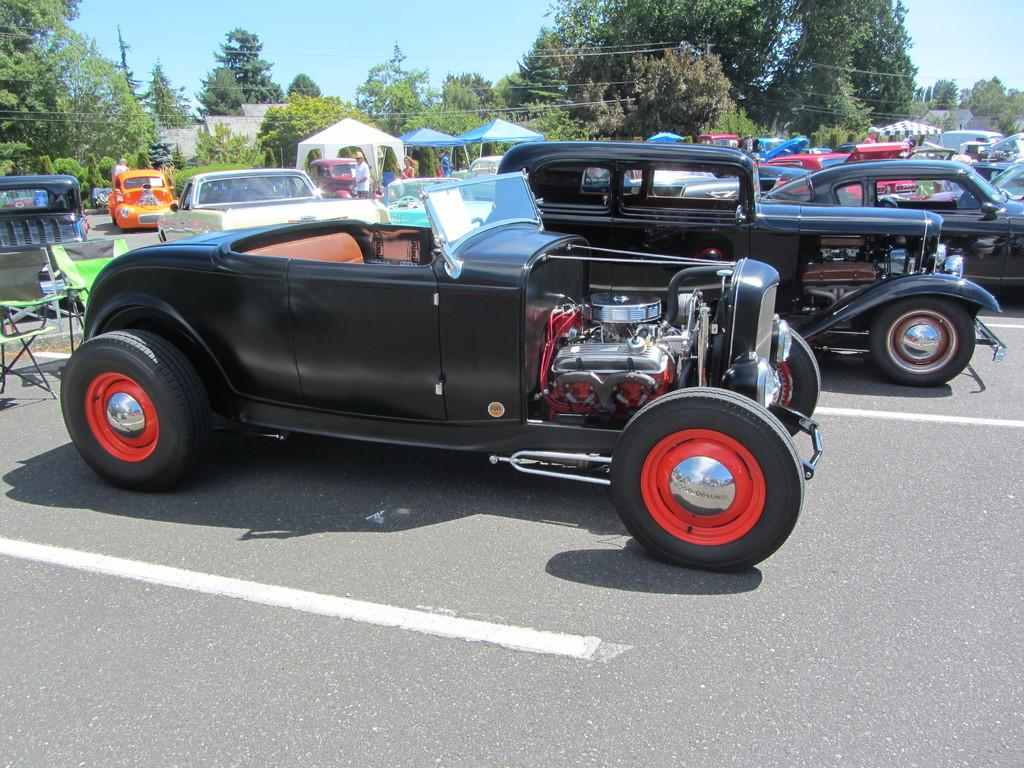What can be seen on the road in the image? There are vehicles on the road in the image. What type of furniture is present in the image? There are chairs in the image. What is visible in the background of the image? There is a roof top, trees, people, and the sky visible in the background. What type of trousers is the snail wearing in the image? There is no snail or trousers present in the image. Can you tell me what the father is doing in the image? There is no reference to a father or any specific actions in the image. 